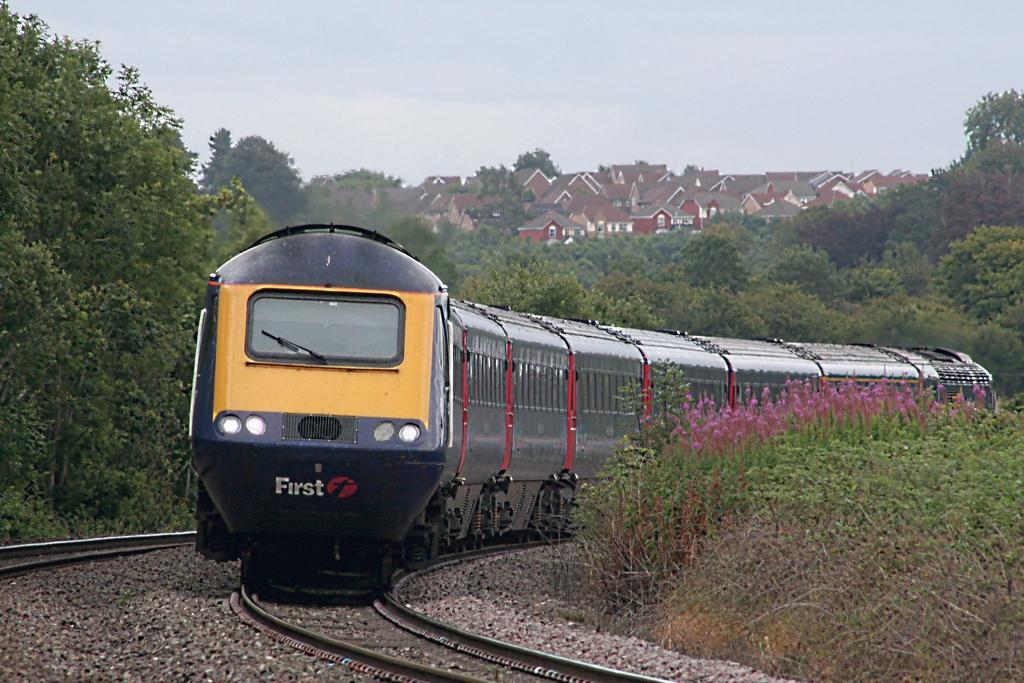What is the weather like in the image? There is rain on the railway track in the image. What type of vegetation can be seen in the image? There are plants, flowers, and trees in the image. What is visible in the background of the image? The sky and trees are visible in the background of the image. How many mittens can be seen in the image? There are no mittens present in the image. What type of pleasure can be observed in the image? The image does not depict any specific pleasure or activity; it shows rain on a railway track and vegetation. 